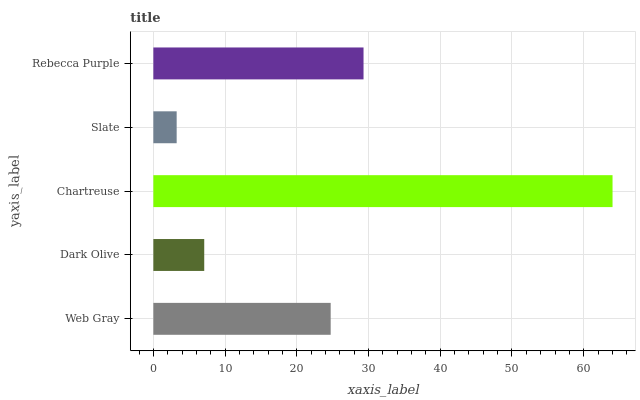Is Slate the minimum?
Answer yes or no. Yes. Is Chartreuse the maximum?
Answer yes or no. Yes. Is Dark Olive the minimum?
Answer yes or no. No. Is Dark Olive the maximum?
Answer yes or no. No. Is Web Gray greater than Dark Olive?
Answer yes or no. Yes. Is Dark Olive less than Web Gray?
Answer yes or no. Yes. Is Dark Olive greater than Web Gray?
Answer yes or no. No. Is Web Gray less than Dark Olive?
Answer yes or no. No. Is Web Gray the high median?
Answer yes or no. Yes. Is Web Gray the low median?
Answer yes or no. Yes. Is Chartreuse the high median?
Answer yes or no. No. Is Slate the low median?
Answer yes or no. No. 